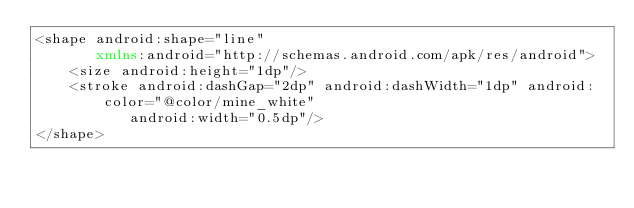Convert code to text. <code><loc_0><loc_0><loc_500><loc_500><_XML_><shape android:shape="line"
       xmlns:android="http://schemas.android.com/apk/res/android">
    <size android:height="1dp"/>
    <stroke android:dashGap="2dp" android:dashWidth="1dp" android:color="@color/mine_white"
           android:width="0.5dp"/>
</shape></code> 